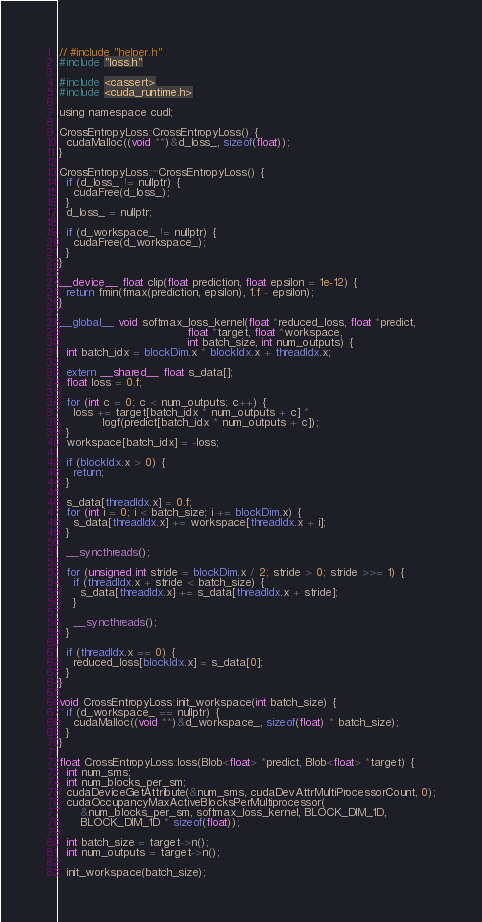<code> <loc_0><loc_0><loc_500><loc_500><_Cuda_>// #include "helper.h"
#include "loss.h"

#include <cassert>
#include <cuda_runtime.h>

using namespace cudl;

CrossEntropyLoss::CrossEntropyLoss() {
  cudaMalloc((void **)&d_loss_, sizeof(float));
}

CrossEntropyLoss::~CrossEntropyLoss() {
  if (d_loss_ != nullptr) {
    cudaFree(d_loss_);
  }
  d_loss_ = nullptr;

  if (d_workspace_ != nullptr) {
    cudaFree(d_workspace_);
  }
}

__device__ float clip(float prediction, float epsilon = 1e-12) {
  return fmin(fmax(prediction, epsilon), 1.f - epsilon);
}

__global__ void softmax_loss_kernel(float *reduced_loss, float *predict,
                                    float *target, float *workspace,
                                    int batch_size, int num_outputs) {
  int batch_idx = blockDim.x * blockIdx.x + threadIdx.x;

  extern __shared__ float s_data[];
  float loss = 0.f;

  for (int c = 0; c < num_outputs; c++) {
    loss += target[batch_idx * num_outputs + c] *
            logf(predict[batch_idx * num_outputs + c]);
  }
  workspace[batch_idx] = -loss;

  if (blockIdx.x > 0) {
    return;
  }

  s_data[threadIdx.x] = 0.f;
  for (int i = 0; i < batch_size; i += blockDim.x) {
    s_data[threadIdx.x] += workspace[threadIdx.x + i];
  }

  __syncthreads();

  for (unsigned int stride = blockDim.x / 2; stride > 0; stride >>= 1) {
    if (threadIdx.x + stride < batch_size) {
      s_data[threadIdx.x] += s_data[threadIdx.x + stride];
    }

    __syncthreads();
  }

  if (threadIdx.x == 0) {
    reduced_loss[blockIdx.x] = s_data[0];
  }
}

void CrossEntropyLoss::init_workspace(int batch_size) {
  if (d_workspace_ == nullptr) {
    cudaMalloc((void **)&d_workspace_, sizeof(float) * batch_size);
  }
}

float CrossEntropyLoss::loss(Blob<float> *predict, Blob<float> *target) {
  int num_sms;
  int num_blocks_per_sm;
  cudaDeviceGetAttribute(&num_sms, cudaDevAttrMultiProcessorCount, 0);
  cudaOccupancyMaxActiveBlocksPerMultiprocessor(
      &num_blocks_per_sm, softmax_loss_kernel, BLOCK_DIM_1D,
      BLOCK_DIM_1D * sizeof(float));

  int batch_size = target->n();
  int num_outputs = target->n();

  init_workspace(batch_size);
</code> 